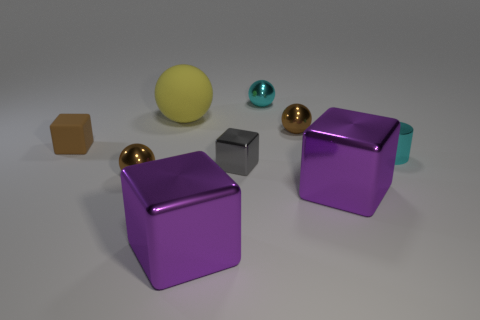Subtract all green balls. How many purple cubes are left? 2 Subtract all tiny brown blocks. How many blocks are left? 3 Subtract all brown cubes. How many cubes are left? 3 Add 1 small gray cylinders. How many objects exist? 10 Subtract all blue balls. Subtract all cyan cylinders. How many balls are left? 4 Subtract all balls. How many objects are left? 5 Subtract all tiny rubber objects. Subtract all large things. How many objects are left? 5 Add 5 purple metal blocks. How many purple metal blocks are left? 7 Add 9 cyan cylinders. How many cyan cylinders exist? 10 Subtract 0 green balls. How many objects are left? 9 